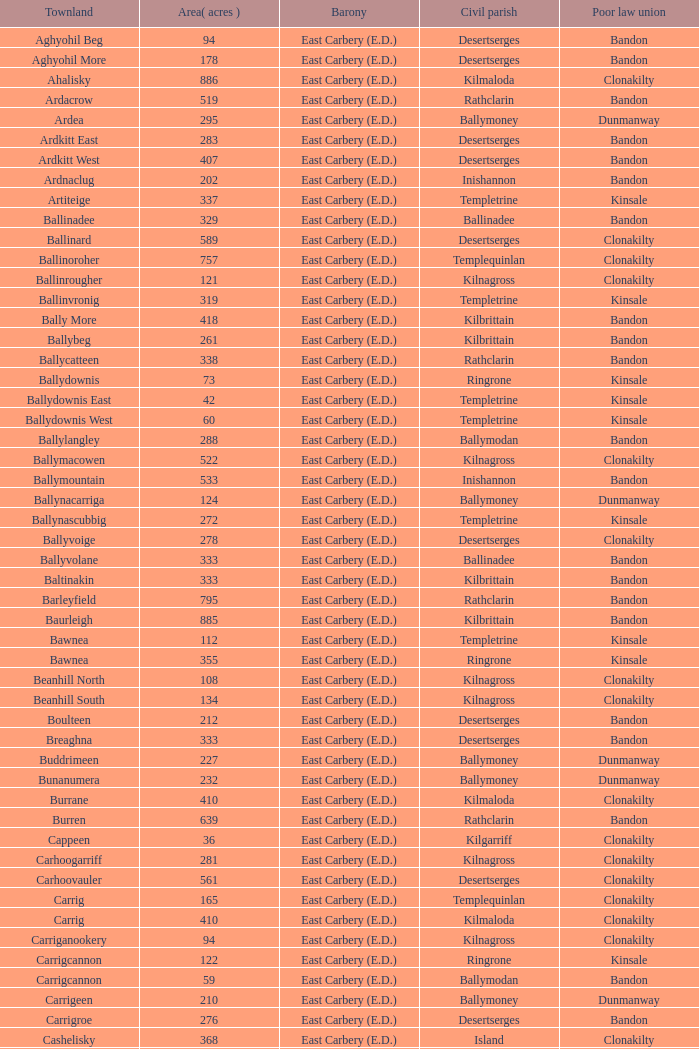What is the poor law coalition of the ardacrow townland? Bandon. 